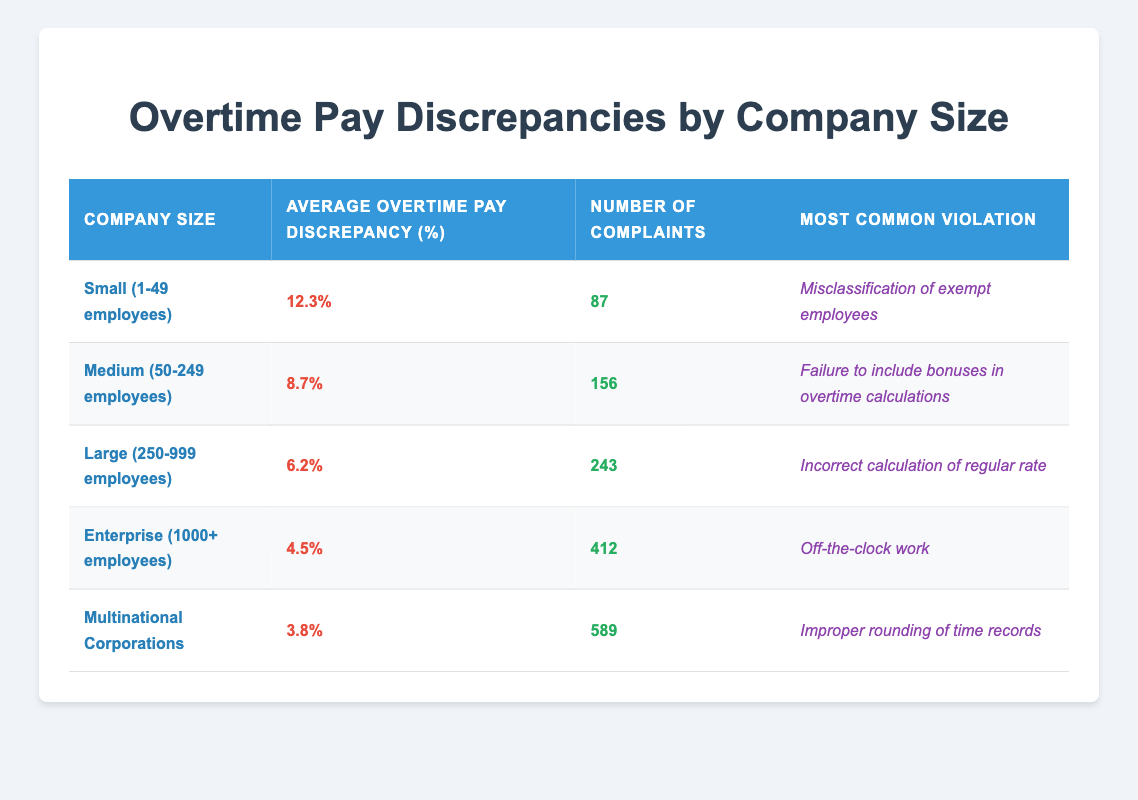What is the average overtime pay discrepancy for Small companies? The table indicates that Small companies (1-49 employees) have an average overtime pay discrepancy of 12.3%.
Answer: 12.3% Which company size has the highest number of complaints? By comparing the "Number of Complaints" column, Enterprise (1000+ employees) has 412 complaints, which is higher than all other sizes listed.
Answer: Enterprise What is the most common violation for Medium-sized companies? The table shows that the most common violation for Medium companies (50-249 employees) is the failure to include bonuses in overtime calculations.
Answer: Failure to include bonuses in overtime calculations What is the difference in average overtime pay discrepancies between Small and Large companies? The average overtime pay discrepancy for Small companies is 12.3%, and for Large companies, it is 6.2%. The difference is 12.3% - 6.2% = 6.1%.
Answer: 6.1% Is the average overtime pay discrepancy for Multinational Corporations less than 5%? The table states that the average overtime pay discrepancy for Multinational Corporations is 3.8%, which is less than 5%.
Answer: Yes What is the total number of complaints across all company sizes listed in the table? To find the total, add the number of complaints: 87 (Small) + 156 (Medium) + 243 (Large) + 412 (Enterprise) + 589 (Multinational) = 1587.
Answer: 1587 Which company size has the lowest average overtime pay discrepancy? The table indicates that Multinational Corporations have the lowest average overtime pay discrepancy at 3.8%.
Answer: Multinational Corporations What is the average overtime pay discrepancy for Large companies compared to Enterprise companies? The average for Large companies is 6.2%, and for Enterprise companies, it's 4.5%. So, large companies' discrepancy is 6.2% - 4.5% = 1.7% higher than enterprise.
Answer: 1.7% higher 